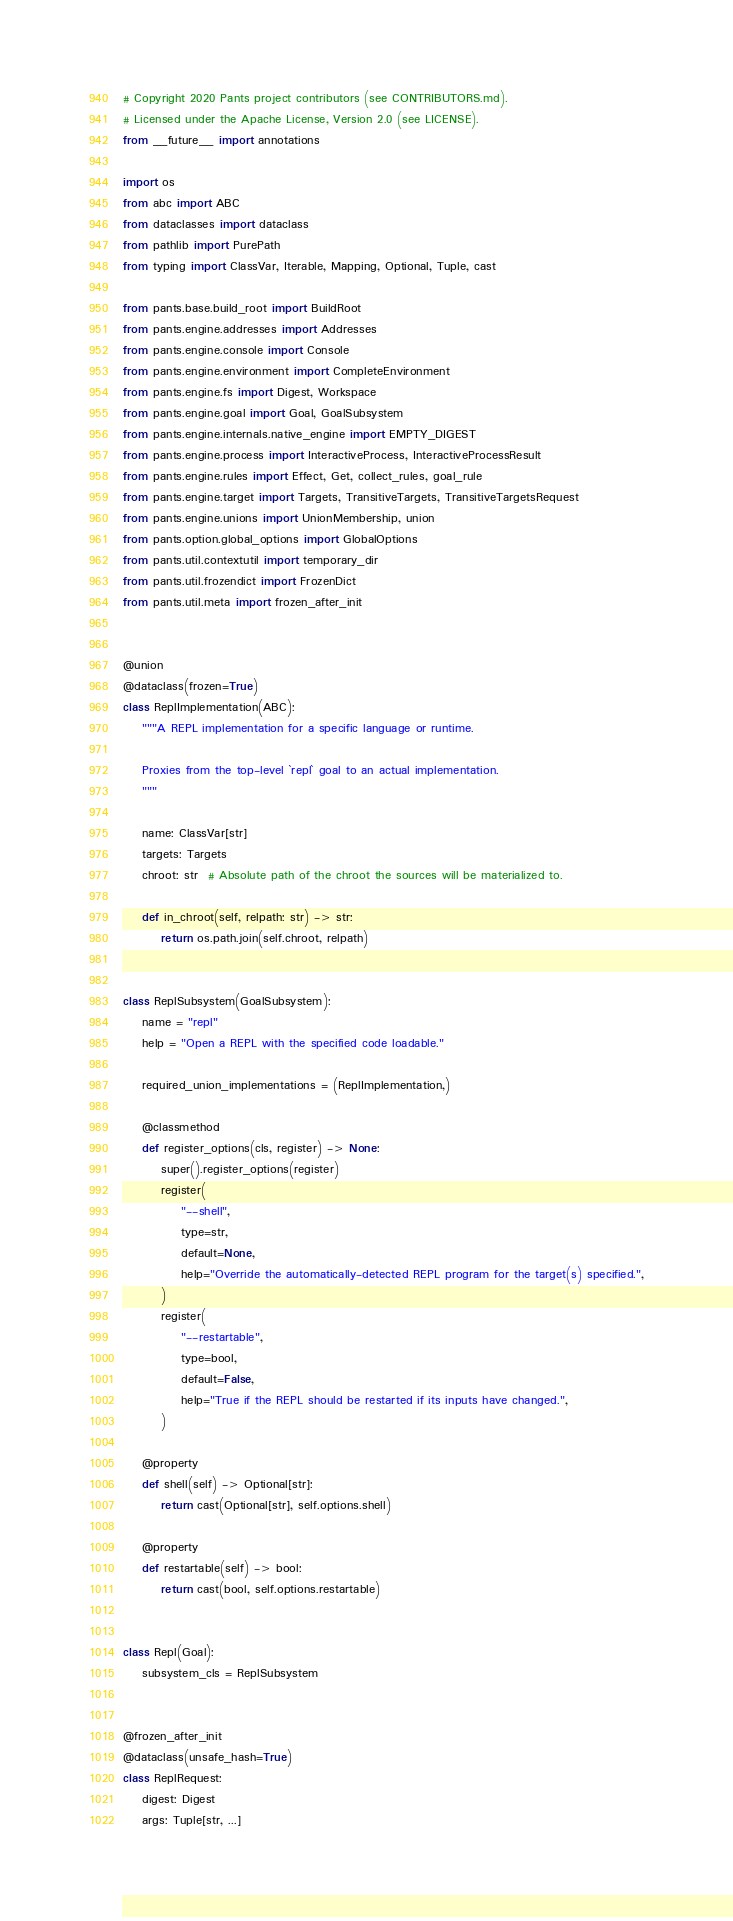<code> <loc_0><loc_0><loc_500><loc_500><_Python_># Copyright 2020 Pants project contributors (see CONTRIBUTORS.md).
# Licensed under the Apache License, Version 2.0 (see LICENSE).
from __future__ import annotations

import os
from abc import ABC
from dataclasses import dataclass
from pathlib import PurePath
from typing import ClassVar, Iterable, Mapping, Optional, Tuple, cast

from pants.base.build_root import BuildRoot
from pants.engine.addresses import Addresses
from pants.engine.console import Console
from pants.engine.environment import CompleteEnvironment
from pants.engine.fs import Digest, Workspace
from pants.engine.goal import Goal, GoalSubsystem
from pants.engine.internals.native_engine import EMPTY_DIGEST
from pants.engine.process import InteractiveProcess, InteractiveProcessResult
from pants.engine.rules import Effect, Get, collect_rules, goal_rule
from pants.engine.target import Targets, TransitiveTargets, TransitiveTargetsRequest
from pants.engine.unions import UnionMembership, union
from pants.option.global_options import GlobalOptions
from pants.util.contextutil import temporary_dir
from pants.util.frozendict import FrozenDict
from pants.util.meta import frozen_after_init


@union
@dataclass(frozen=True)
class ReplImplementation(ABC):
    """A REPL implementation for a specific language or runtime.

    Proxies from the top-level `repl` goal to an actual implementation.
    """

    name: ClassVar[str]
    targets: Targets
    chroot: str  # Absolute path of the chroot the sources will be materialized to.

    def in_chroot(self, relpath: str) -> str:
        return os.path.join(self.chroot, relpath)


class ReplSubsystem(GoalSubsystem):
    name = "repl"
    help = "Open a REPL with the specified code loadable."

    required_union_implementations = (ReplImplementation,)

    @classmethod
    def register_options(cls, register) -> None:
        super().register_options(register)
        register(
            "--shell",
            type=str,
            default=None,
            help="Override the automatically-detected REPL program for the target(s) specified.",
        )
        register(
            "--restartable",
            type=bool,
            default=False,
            help="True if the REPL should be restarted if its inputs have changed.",
        )

    @property
    def shell(self) -> Optional[str]:
        return cast(Optional[str], self.options.shell)

    @property
    def restartable(self) -> bool:
        return cast(bool, self.options.restartable)


class Repl(Goal):
    subsystem_cls = ReplSubsystem


@frozen_after_init
@dataclass(unsafe_hash=True)
class ReplRequest:
    digest: Digest
    args: Tuple[str, ...]</code> 